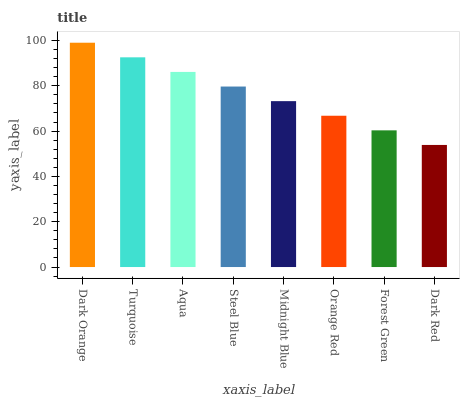Is Dark Red the minimum?
Answer yes or no. Yes. Is Dark Orange the maximum?
Answer yes or no. Yes. Is Turquoise the minimum?
Answer yes or no. No. Is Turquoise the maximum?
Answer yes or no. No. Is Dark Orange greater than Turquoise?
Answer yes or no. Yes. Is Turquoise less than Dark Orange?
Answer yes or no. Yes. Is Turquoise greater than Dark Orange?
Answer yes or no. No. Is Dark Orange less than Turquoise?
Answer yes or no. No. Is Steel Blue the high median?
Answer yes or no. Yes. Is Midnight Blue the low median?
Answer yes or no. Yes. Is Forest Green the high median?
Answer yes or no. No. Is Dark Orange the low median?
Answer yes or no. No. 